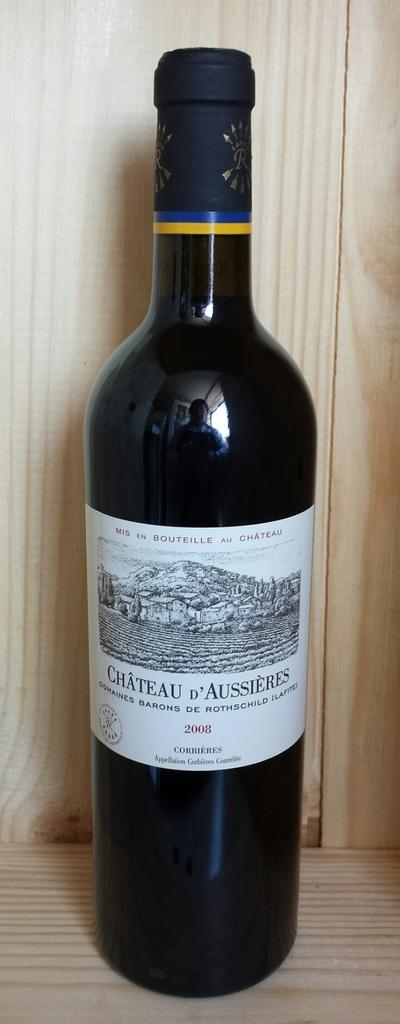<image>
Describe the image concisely. Dark bottle with a white label that says "Cheateau d'Aussieres" on top of a wooden surface. 